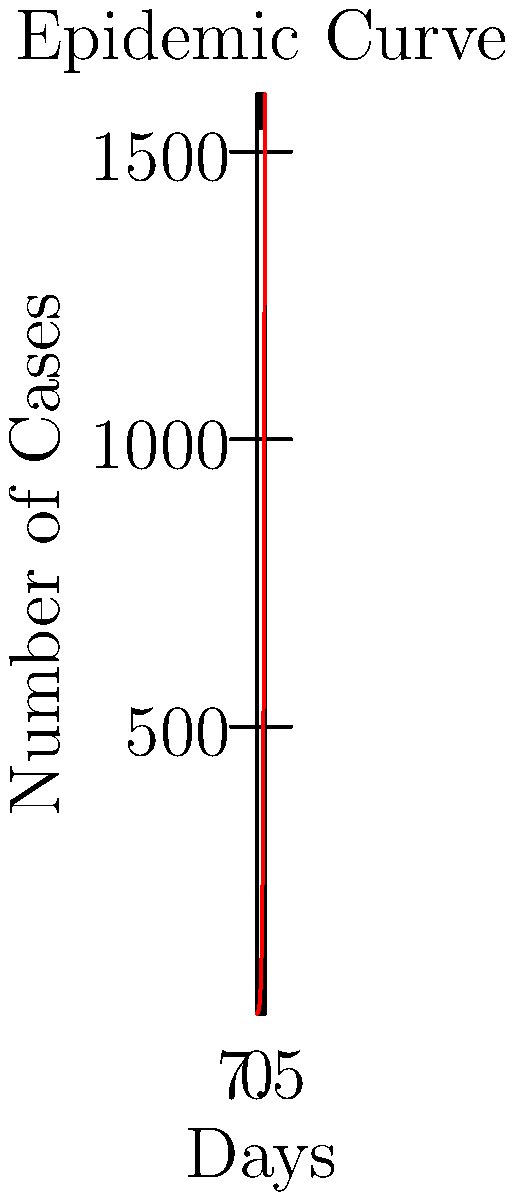Based on the epidemic curve shown, estimate the rate of spread (R0) of the disease during the first 7 days of the outbreak. Assume that the generation time (time between successive cases in a chain of transmission) is 3 days. To estimate the basic reproduction number (R0) using the epidemic curve, we'll follow these steps:

1. Identify the number of cases at day 0 and day 7:
   Day 0: 1 case
   Day 7: 54 cases

2. Calculate the number of generations in 7 days:
   Number of generations = 7 days ÷ 3 days per generation = 2.33 generations

3. Calculate the growth factor:
   Growth factor = Final number of cases ÷ Initial number of cases
   Growth factor = 54 ÷ 1 = 54

4. Calculate R0:
   $R0 = (Growth factor)^{1/number of generations}$
   $R0 = 54^{1/2.33}$
   $R0 \approx 3.98$

Therefore, the estimated R0 for this disease during the first 7 days of the outbreak is approximately 3.98.
Answer: $R0 \approx 3.98$ 